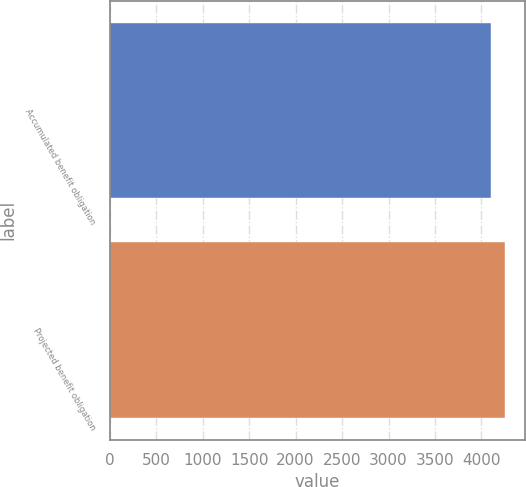Convert chart to OTSL. <chart><loc_0><loc_0><loc_500><loc_500><bar_chart><fcel>Accumulated benefit obligation<fcel>Projected benefit obligation<nl><fcel>4104<fcel>4257.2<nl></chart> 